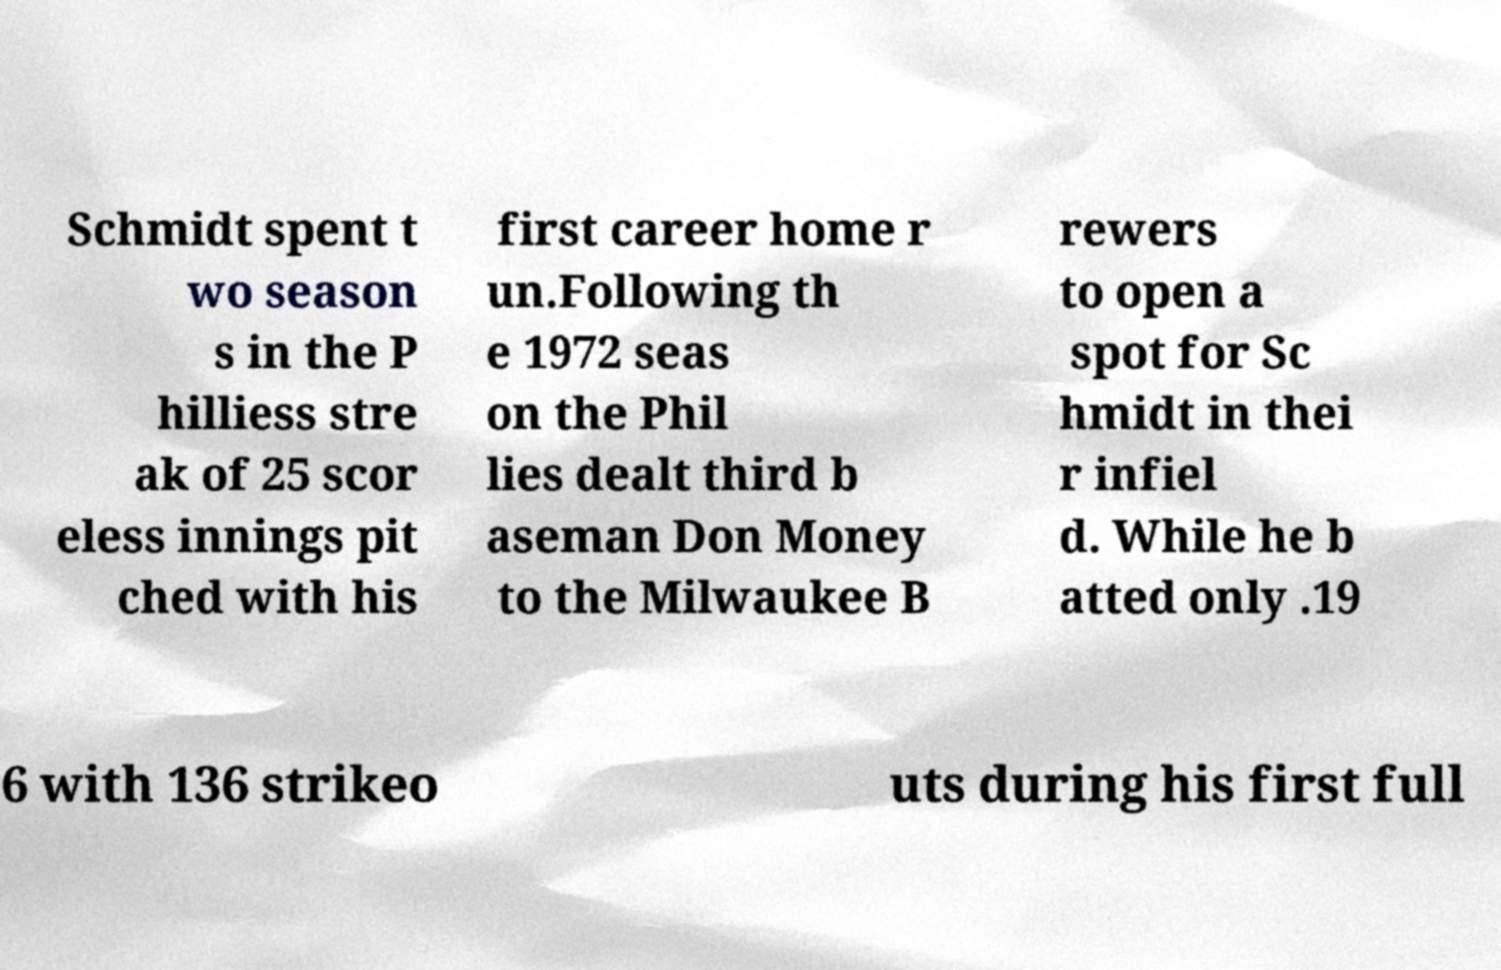Could you extract and type out the text from this image? Schmidt spent t wo season s in the P hilliess stre ak of 25 scor eless innings pit ched with his first career home r un.Following th e 1972 seas on the Phil lies dealt third b aseman Don Money to the Milwaukee B rewers to open a spot for Sc hmidt in thei r infiel d. While he b atted only .19 6 with 136 strikeo uts during his first full 